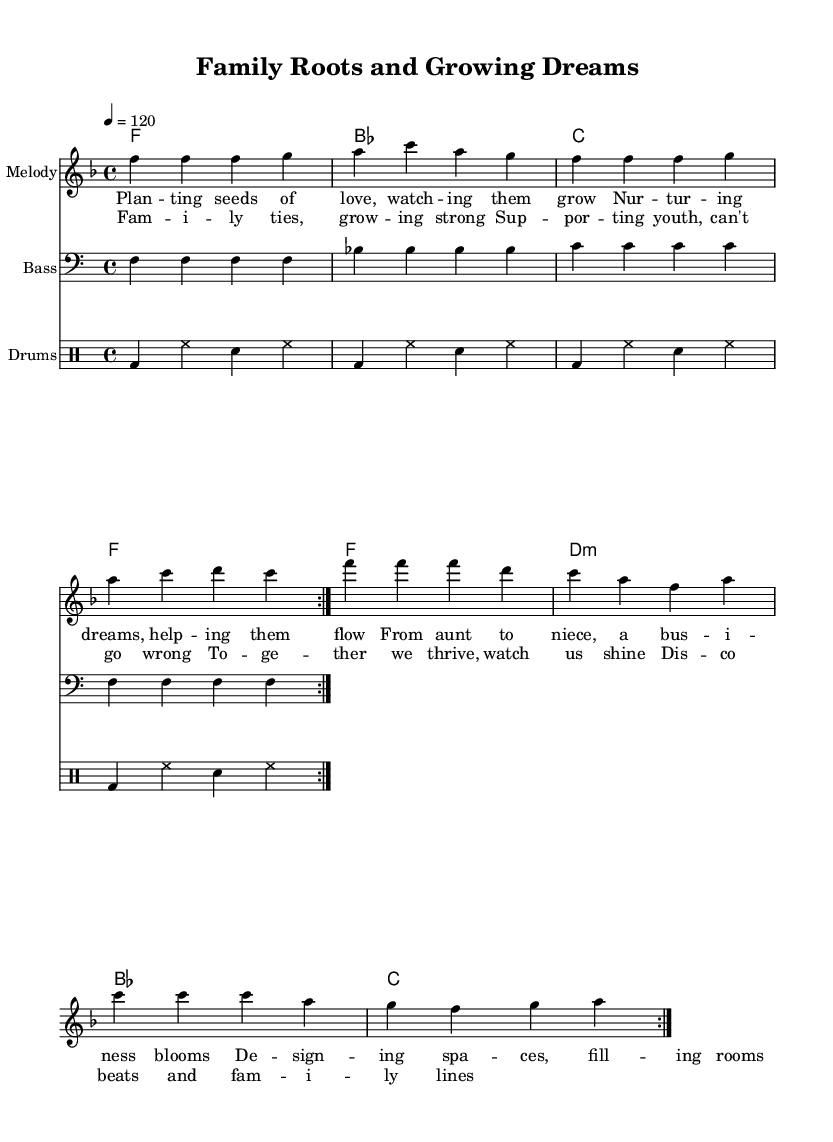What is the key signature of this music? The key signature is F major, which has one flat (B flat). This can be determined by looking at the beginning of the sheet music where the key signature is indicated.
Answer: F major What is the time signature of this music? The time signature is 4/4, which means there are four beats in each measure. This is indicated right after the key signature at the beginning of the music.
Answer: 4/4 What tempo is indicated for this piece? The tempo is indicated as 120 beats per minute, as stated in the tempo marking at the beginning of the music.
Answer: 120 How many measures are repeated in the melody section? The melody section contains a repeat that happens twice. This can be observed by the "repeat volta" markings in the melody part.
Answer: 2 What type of lyrics are included in this sheet music? The lyrics include themes of family connections and supporting young entrepreneurs, as seen in the verses and chorus which describe nurturing dreams and family ties. This is typical for disco anthems that often focus on communal and supportive themes.
Answer: Family connections and supporting young entrepreneurs How many distinct sections are there in the vocal part? There are two distinct sections in the vocal part: verses and chorus. The verses precede the chorus and consist of separate lyrical content, as indicated in the layout of lyrics in the score.
Answer: 2 What can you infer about the overall theme of this disco anthem? The overall theme of the anthem revolves around nurturing familial relationships and encouraging youth, which aligns with the upbeat and supportive ethos often found in disco music. The lyrics echo this through their content focused on growth and support.
Answer: Family and support 